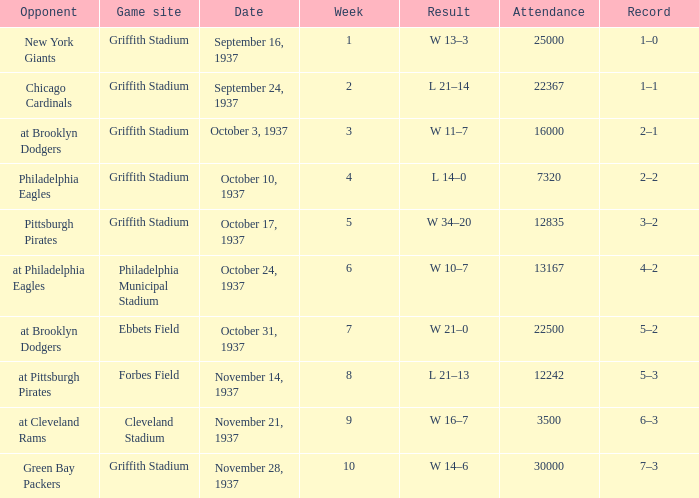What are week 4 results?  L 14–0. 